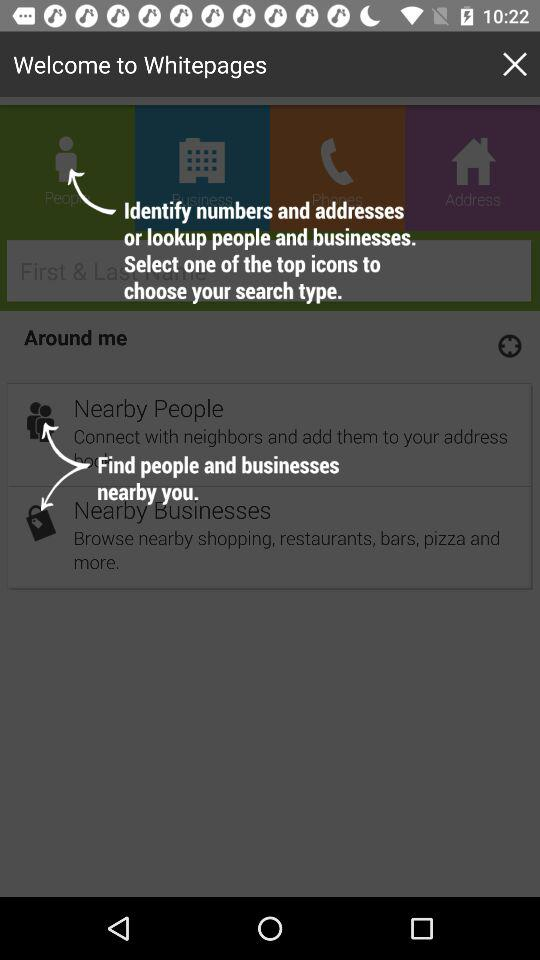What is the application name? The application name is "Whitepages". 